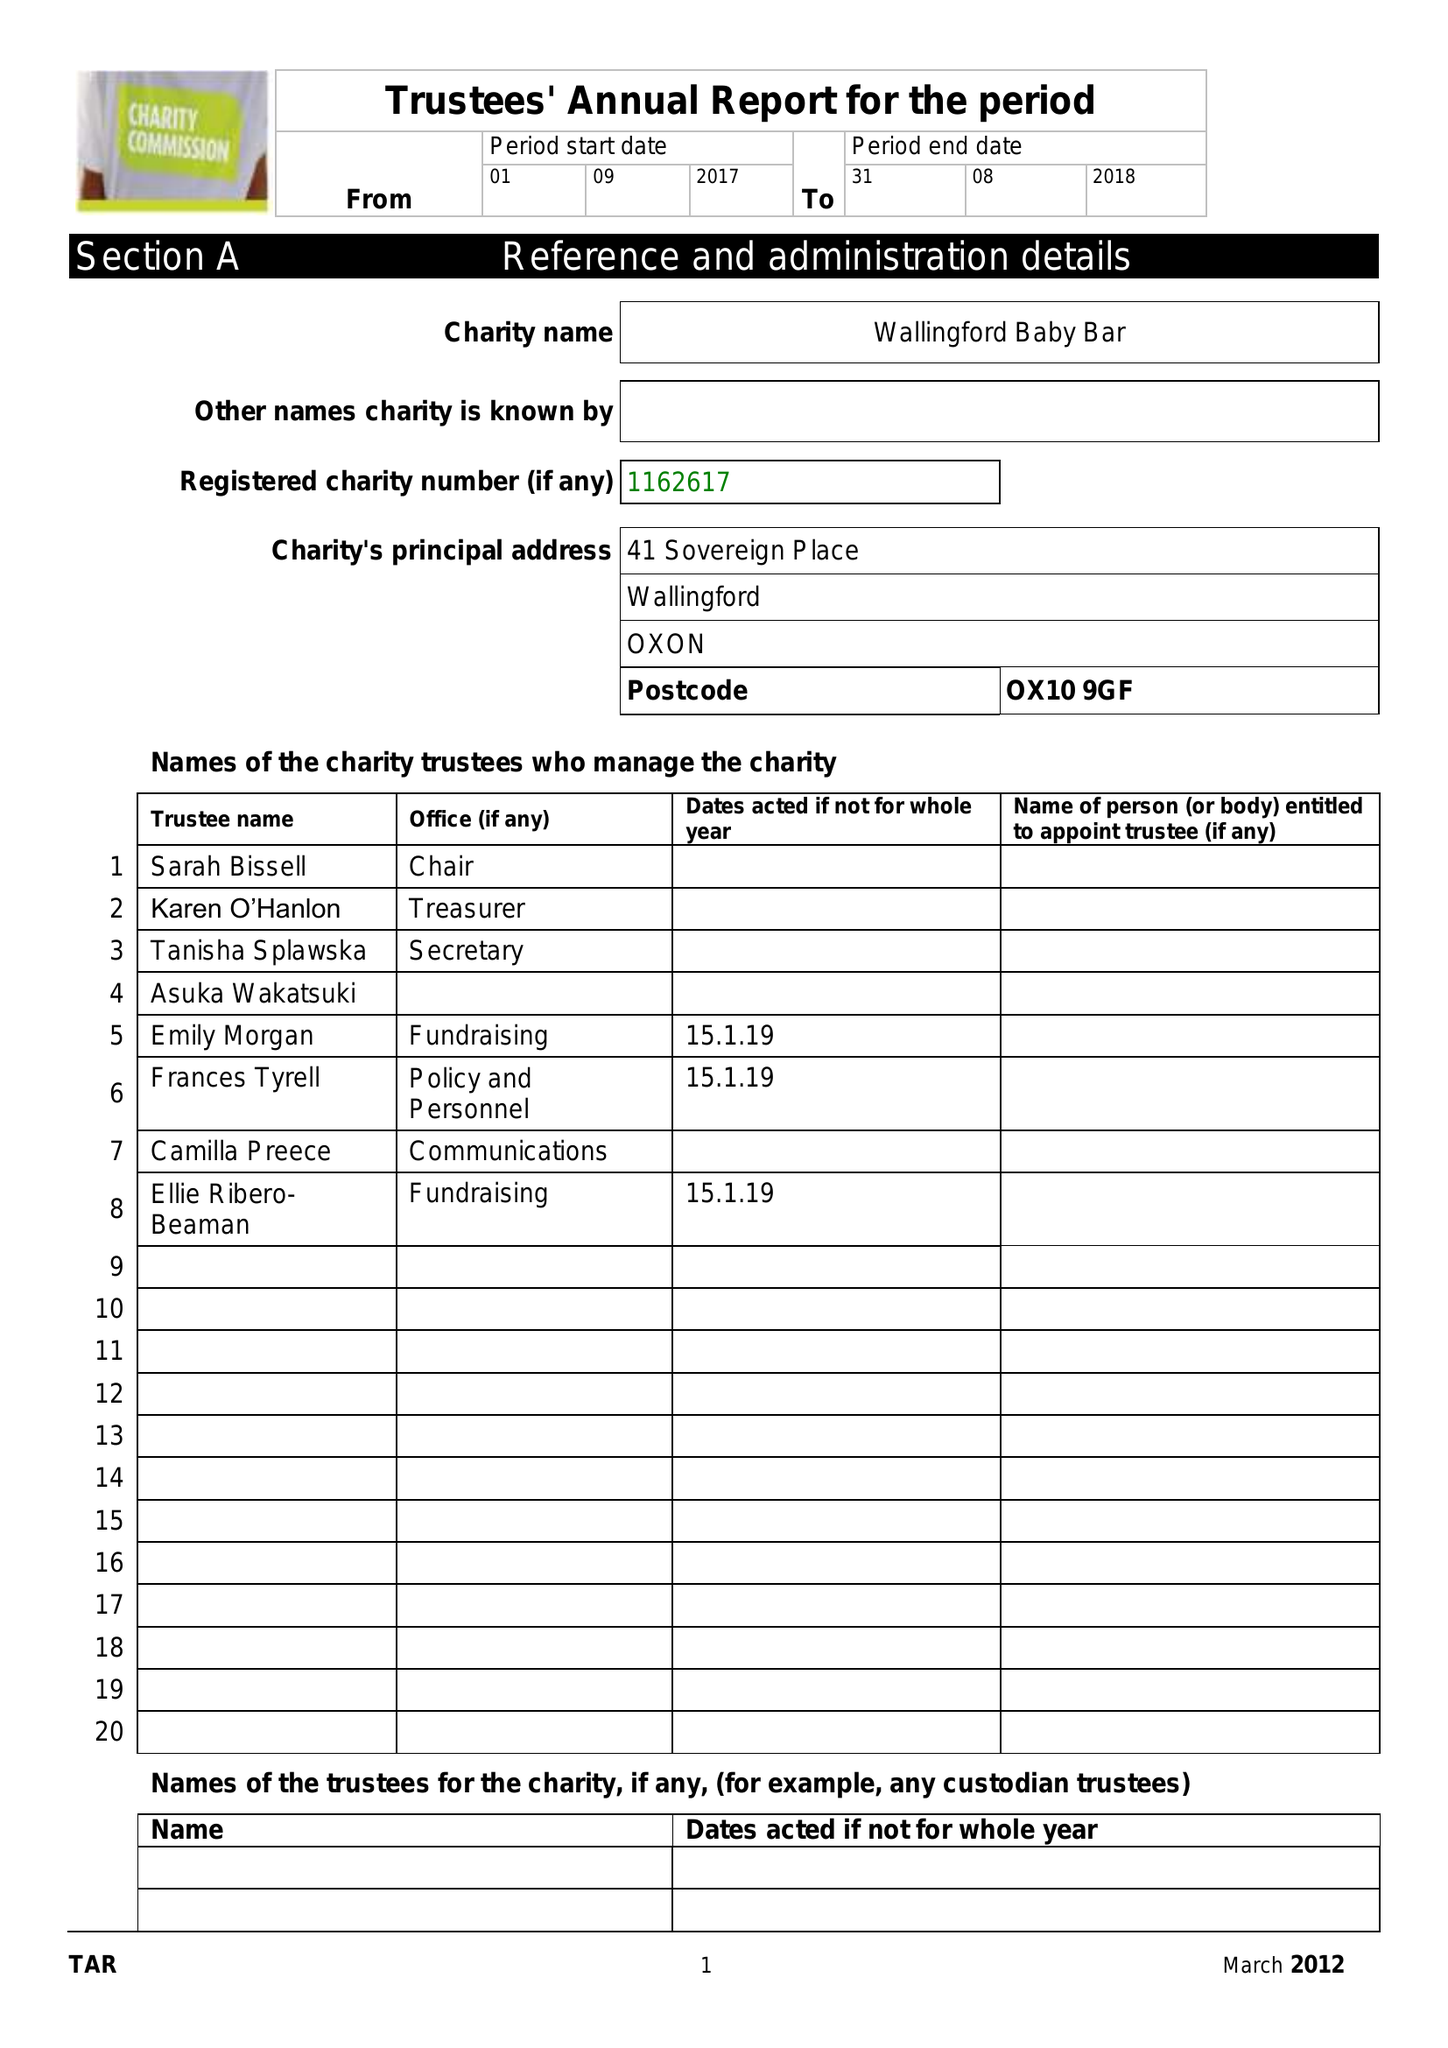What is the value for the charity_number?
Answer the question using a single word or phrase. 1162617 